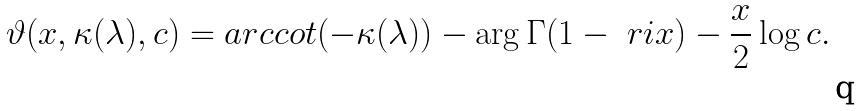Convert formula to latex. <formula><loc_0><loc_0><loc_500><loc_500>\vartheta ( x , \kappa ( \lambda ) , c ) = a r c c o t ( - \kappa ( \lambda ) ) - \arg \Gamma ( 1 - \ r i x ) - \frac { x } { 2 } \log c .</formula> 